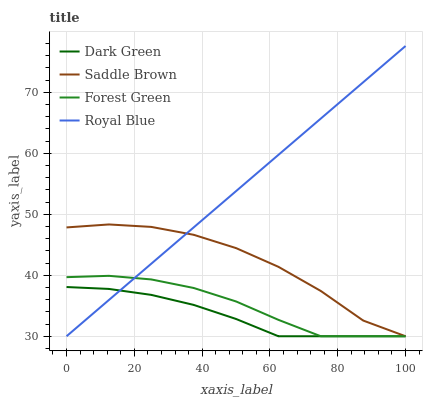Does Dark Green have the minimum area under the curve?
Answer yes or no. Yes. Does Royal Blue have the maximum area under the curve?
Answer yes or no. Yes. Does Forest Green have the minimum area under the curve?
Answer yes or no. No. Does Forest Green have the maximum area under the curve?
Answer yes or no. No. Is Royal Blue the smoothest?
Answer yes or no. Yes. Is Saddle Brown the roughest?
Answer yes or no. Yes. Is Forest Green the smoothest?
Answer yes or no. No. Is Forest Green the roughest?
Answer yes or no. No. Does Royal Blue have the lowest value?
Answer yes or no. Yes. Does Royal Blue have the highest value?
Answer yes or no. Yes. Does Forest Green have the highest value?
Answer yes or no. No. Does Forest Green intersect Royal Blue?
Answer yes or no. Yes. Is Forest Green less than Royal Blue?
Answer yes or no. No. Is Forest Green greater than Royal Blue?
Answer yes or no. No. 